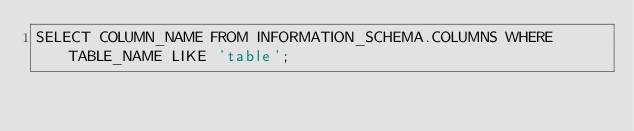<code> <loc_0><loc_0><loc_500><loc_500><_SQL_>SELECT COLUMN_NAME FROM INFORMATION_SCHEMA.COLUMNS WHERE TABLE_NAME LIKE 'table';</code> 